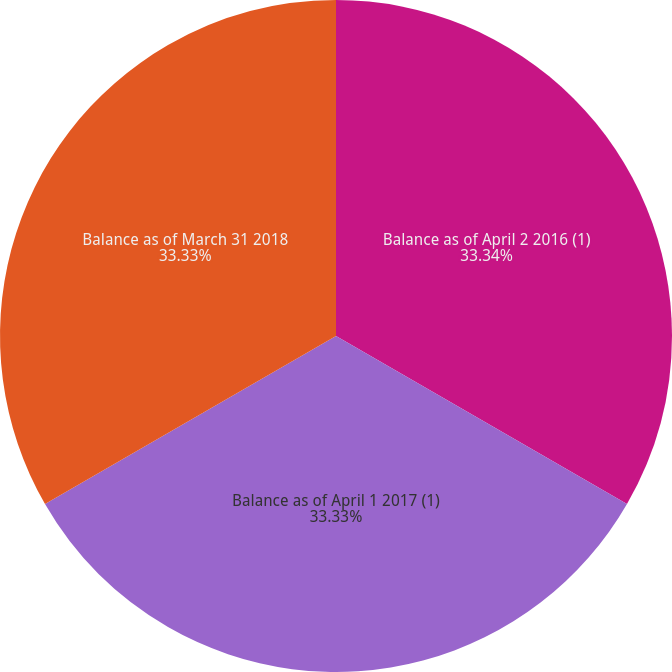Convert chart to OTSL. <chart><loc_0><loc_0><loc_500><loc_500><pie_chart><fcel>Balance as of April 2 2016 (1)<fcel>Balance as of April 1 2017 (1)<fcel>Balance as of March 31 2018<nl><fcel>33.33%<fcel>33.33%<fcel>33.33%<nl></chart> 